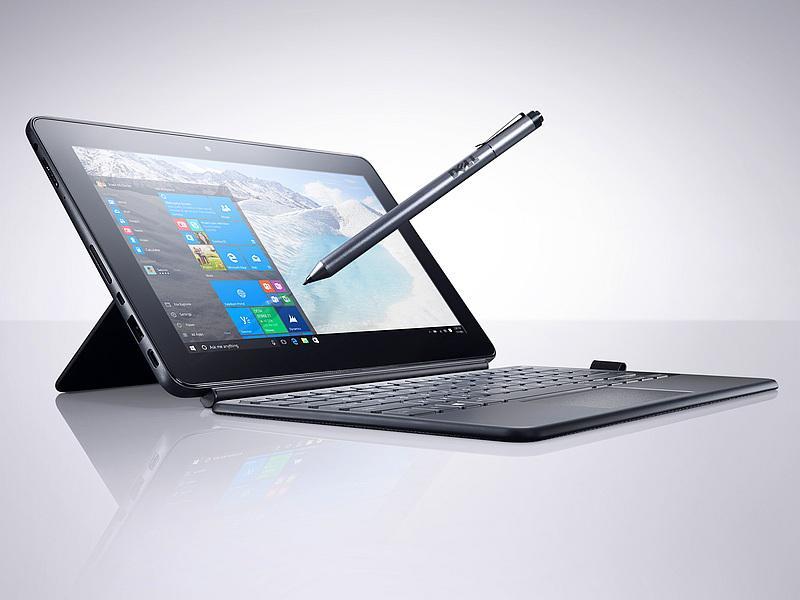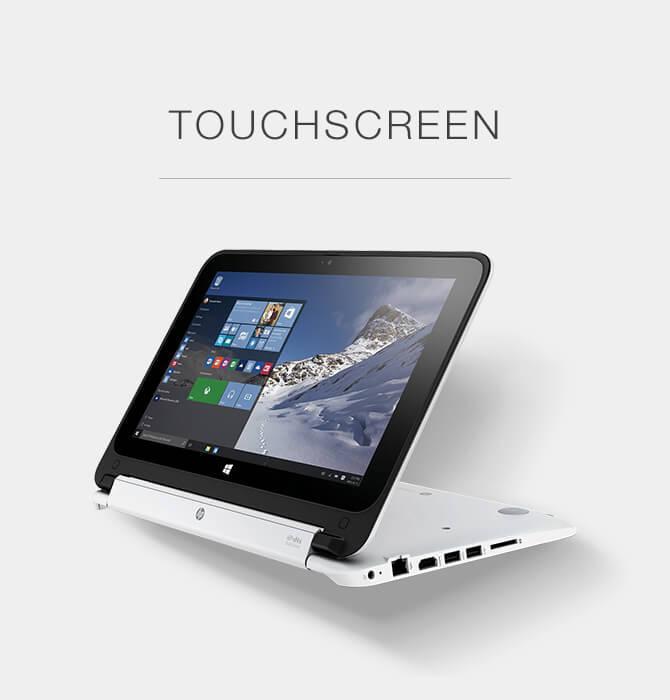The first image is the image on the left, the second image is the image on the right. Evaluate the accuracy of this statement regarding the images: "A pen is touching the screen in one of the images.". Is it true? Answer yes or no. Yes. 